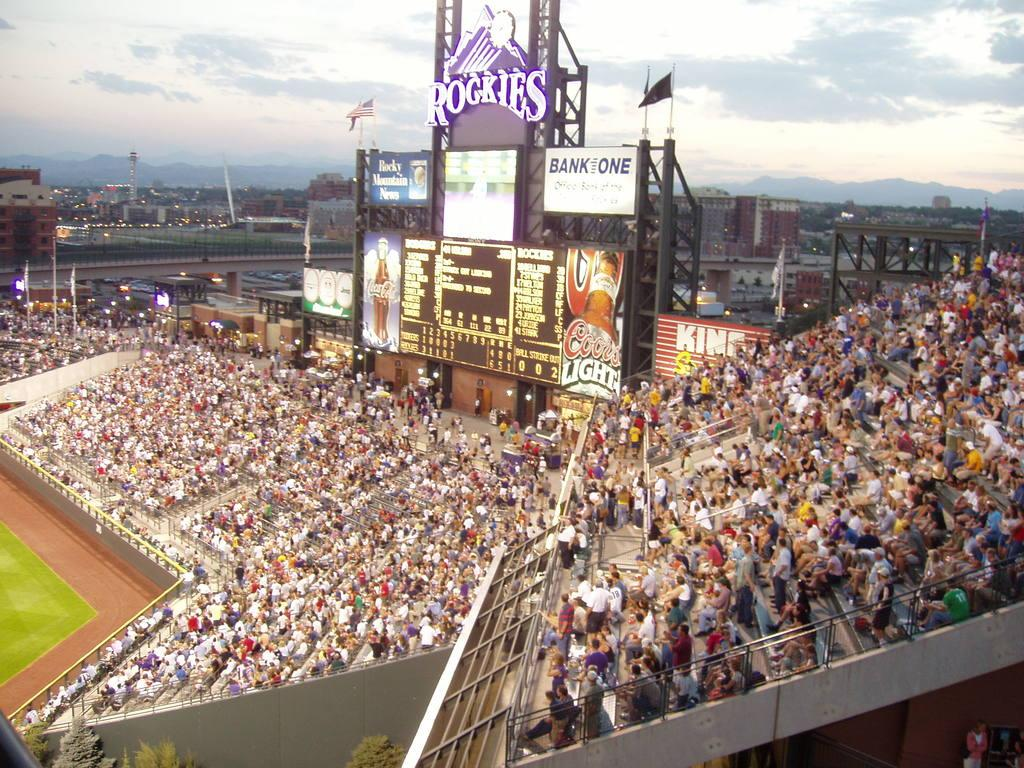<image>
Offer a succinct explanation of the picture presented. A full stadium at a baseball game says Rockies on the stadium sign. 